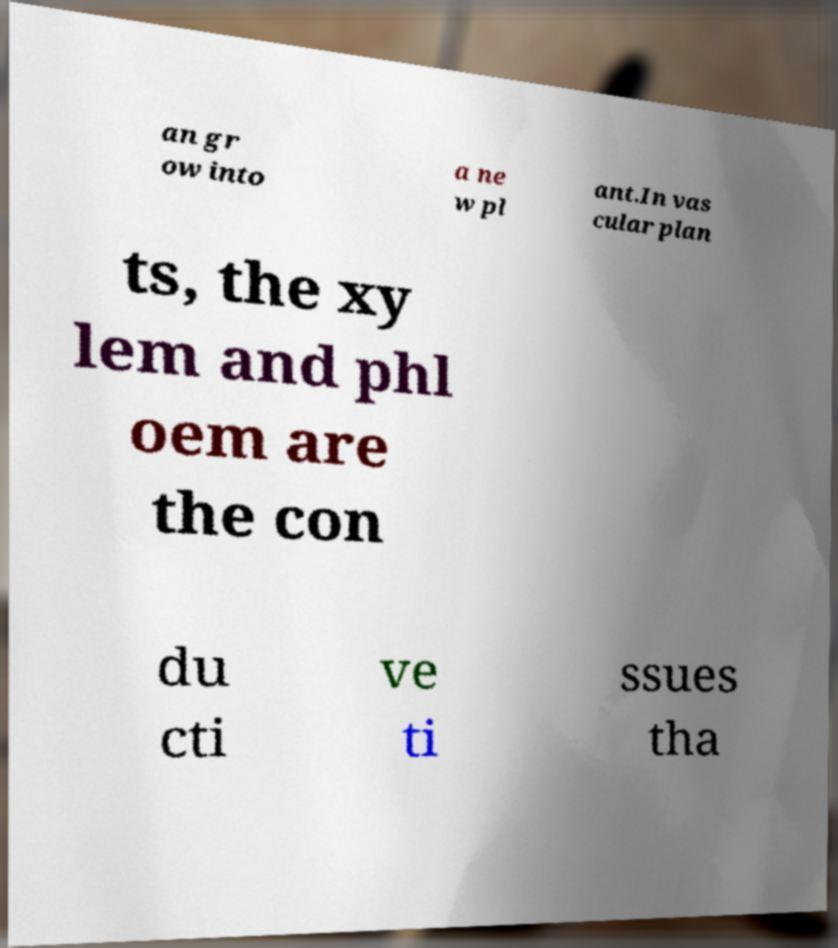There's text embedded in this image that I need extracted. Can you transcribe it verbatim? an gr ow into a ne w pl ant.In vas cular plan ts, the xy lem and phl oem are the con du cti ve ti ssues tha 